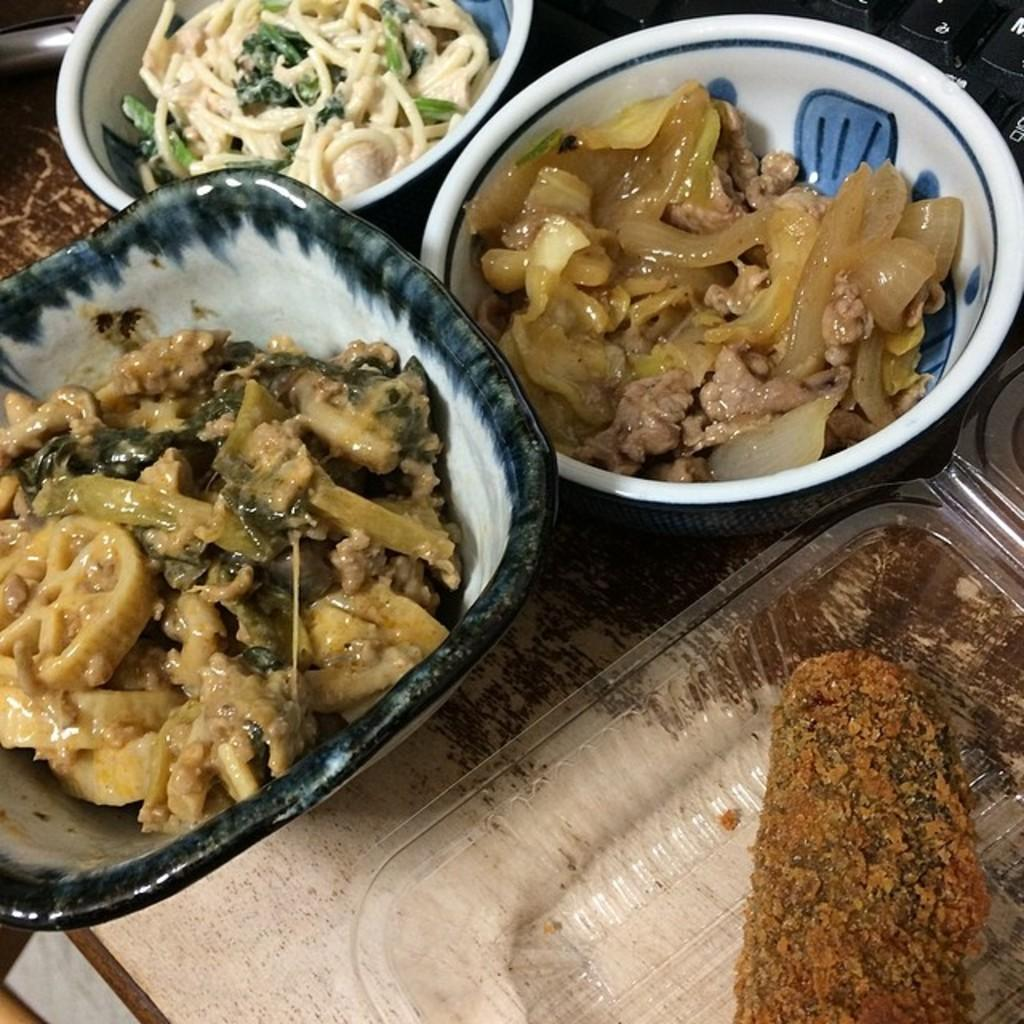What can be seen in the containers in the image? There is food in the containers in the image. What type of leather is used to create the peace symbol in the image? There is no leather or peace symbol present in the image; it only features food in containers. 